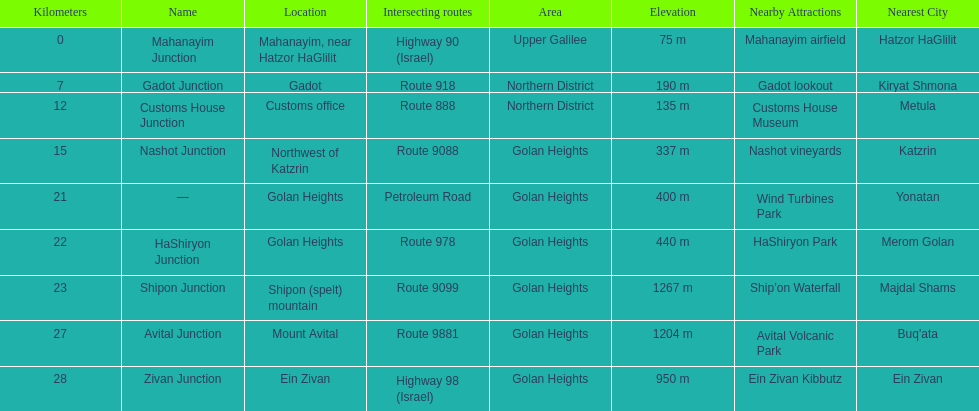What is the last junction on highway 91? Zivan Junction. 